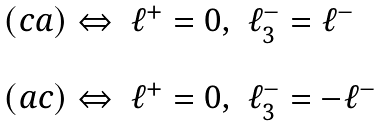<formula> <loc_0><loc_0><loc_500><loc_500>\begin{array} { l l l } ( c a ) \Leftrightarrow & \ell ^ { + } = 0 , & \ell ^ { - } _ { 3 } = \ell ^ { - } \\ & & \\ ( a c ) \Leftrightarrow & \ell ^ { + } = 0 , & \ell ^ { - } _ { 3 } = - \ell ^ { - } \end{array}</formula> 